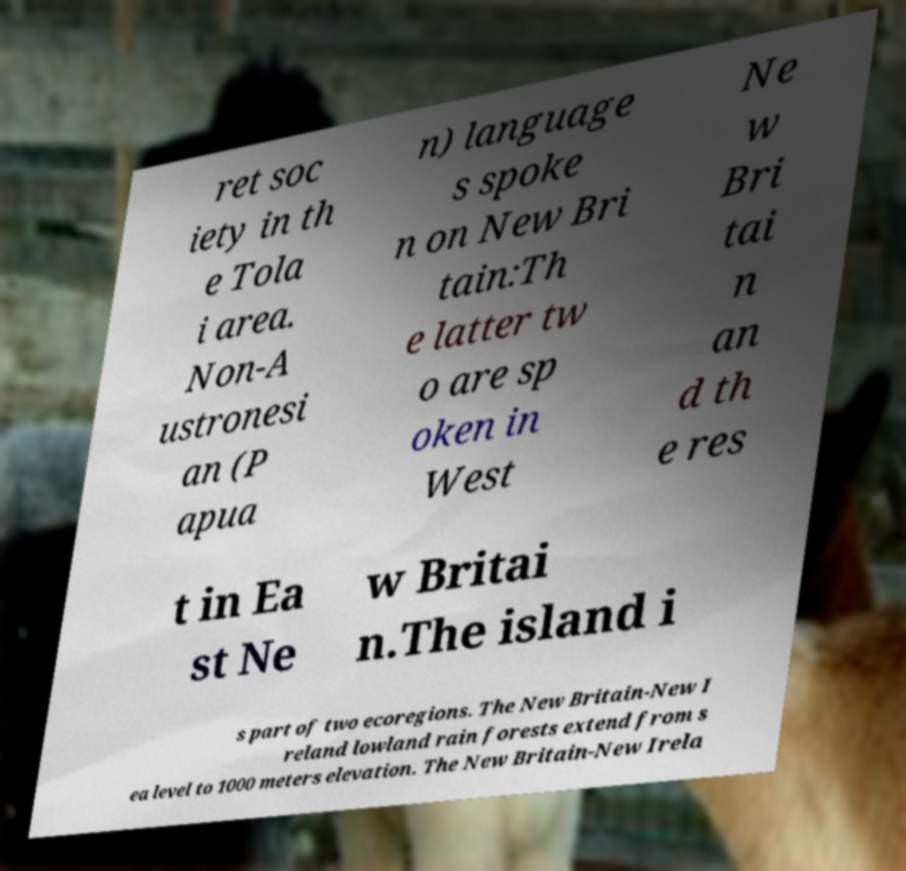There's text embedded in this image that I need extracted. Can you transcribe it verbatim? ret soc iety in th e Tola i area. Non-A ustronesi an (P apua n) language s spoke n on New Bri tain:Th e latter tw o are sp oken in West Ne w Bri tai n an d th e res t in Ea st Ne w Britai n.The island i s part of two ecoregions. The New Britain-New I reland lowland rain forests extend from s ea level to 1000 meters elevation. The New Britain-New Irela 